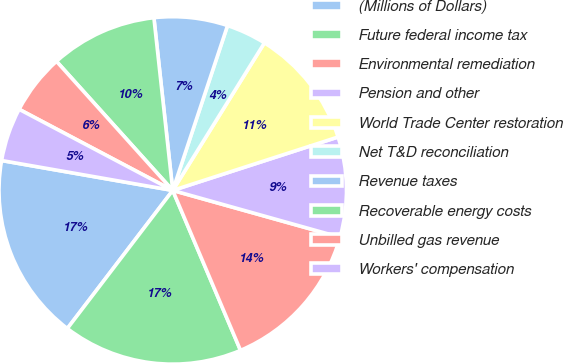Convert chart. <chart><loc_0><loc_0><loc_500><loc_500><pie_chart><fcel>(Millions of Dollars)<fcel>Future federal income tax<fcel>Environmental remediation<fcel>Pension and other<fcel>World Trade Center restoration<fcel>Net T&D reconciliation<fcel>Revenue taxes<fcel>Recoverable energy costs<fcel>Unbilled gas revenue<fcel>Workers' compensation<nl><fcel>17.38%<fcel>16.76%<fcel>14.28%<fcel>9.32%<fcel>11.18%<fcel>3.74%<fcel>6.84%<fcel>9.94%<fcel>5.6%<fcel>4.98%<nl></chart> 